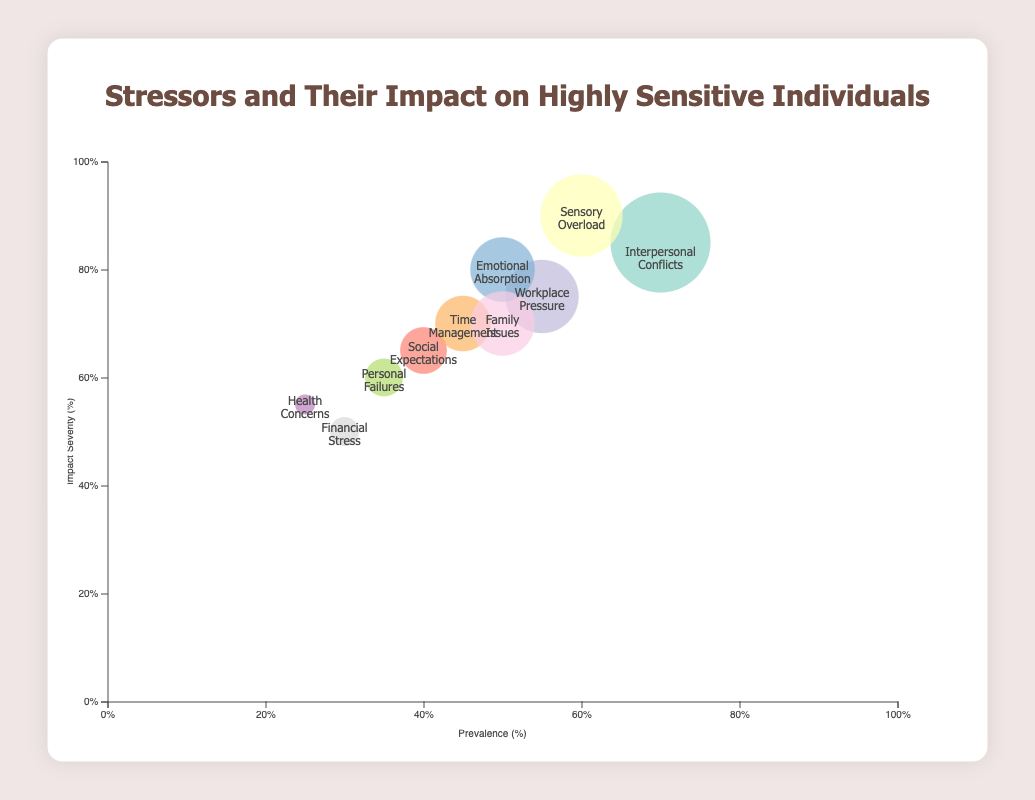What is the title of the figure? The title can be found at the top of the figure. It is intended to describe what the chart is about.
Answer: Stressors and Their Impact on Highly Sensitive Individuals Which stressor has the highest impact severity? Look at the position of the bubbles on the y-axis and identify the one that is highest on the chart. Sensory Overload is at the top with an impact severity of 90%.
Answer: Sensory Overload Which stressor has the lowest prevalence? Check the position of the bubbles along the x-axis and find the one closest to the origin (leftmost). Health Concerns is the leftmost with a prevalence of 25%.
Answer: Health Concerns What is the prevalence of Family Issues? Find the bubble labeled "Family Issues" and refer to its position on the x-axis.
Answer: 50% Which stressor has a higher impact severity, Personal Failures or Emotional Absorption? Compare the vertical positions of the bubbles labeled "Personal Failures" and "Emotional Absorption". Emotional Absorption is higher, indicating a greater impact severity.
Answer: Emotional Absorption Between Interpersonal Conflicts and Sensory Overload, which has a higher prevalence? Compare the horizontal positions of the bubbles labeled "Interpersonal Conflicts" and "Sensory Overload". Interpersonal Conflicts is further to the right on the x-axis.
Answer: Interpersonal Conflicts How many stressors have a prevalence of 50% or more? Identify all bubbles with prevalence values starting from 50% onwards on the x-axis. Count these bubbles: Interpersonal Conflicts, Sensory Overload, Workplace Pressure, Emotional Absorption, and Family Issues.
Answer: 5 Which stressors have both prevalence and impact severity above 70%? Find bubbles that are positioned both to the right of the 70% tick mark on the x-axis and above the 70% tick mark on the y-axis. Interpersonal Conflicts and Sensory Overload fit these criteria.
Answer: Interpersonal Conflicts and Sensory Overload Compare Financial Stress and Health Concerns. Which has a higher impact severity? Look at the vertical positions of the bubbles labeled "Financial Stress" and "Health Concerns" and determine which one is higher. Financial Stress is higher at 50% compared to Health Concerns at 55%.
Answer: Health Concerns 